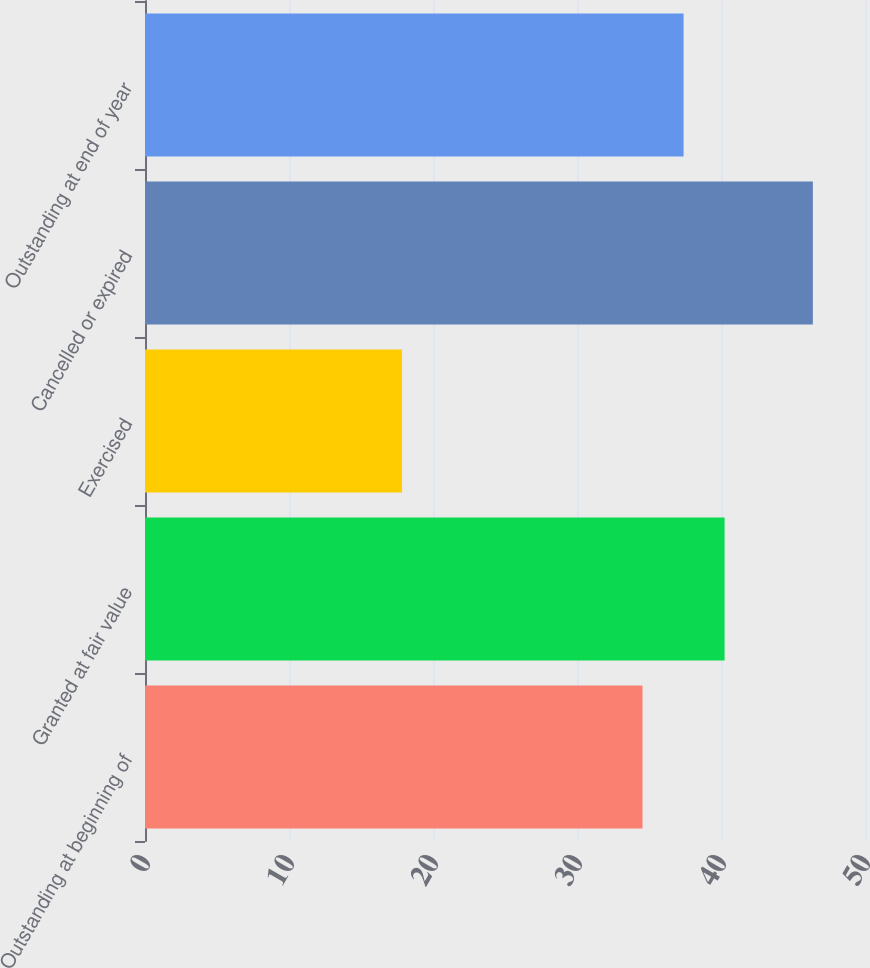Convert chart to OTSL. <chart><loc_0><loc_0><loc_500><loc_500><bar_chart><fcel>Outstanding at beginning of<fcel>Granted at fair value<fcel>Exercised<fcel>Cancelled or expired<fcel>Outstanding at end of year<nl><fcel>34.55<fcel>40.25<fcel>17.85<fcel>46.38<fcel>37.4<nl></chart> 